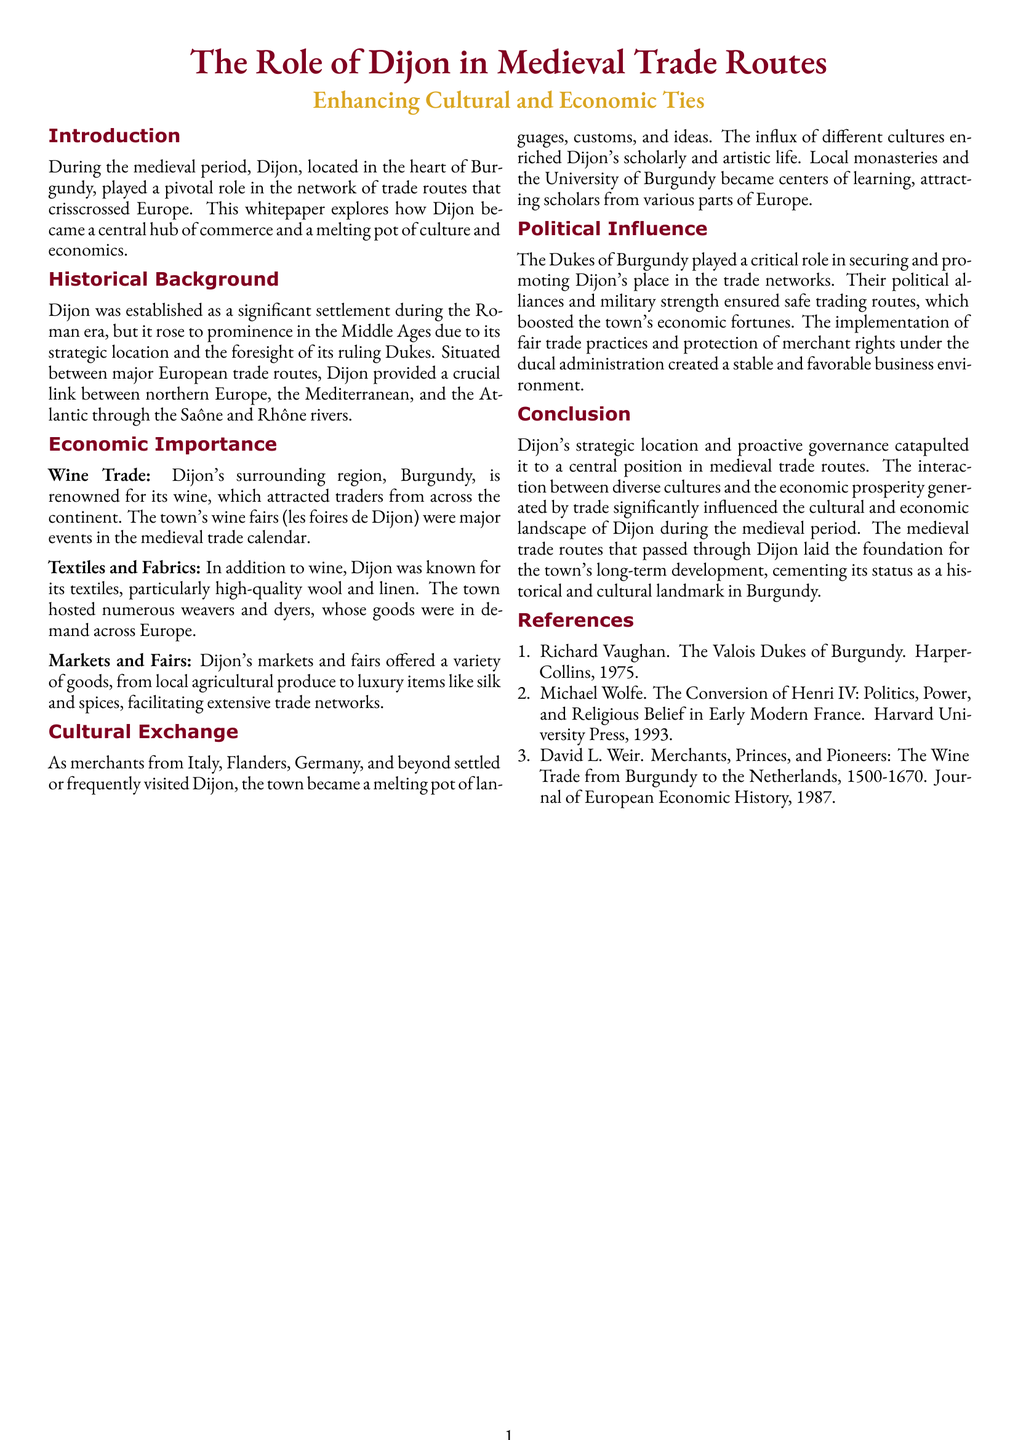what role did Dijon play during the medieval period? Dijon played a pivotal role in the network of trade routes that crisscrossed Europe.
Answer: central hub what attracted traders to Dijon? Traders were attracted to Dijon due to its renowned wine and trade fairs.
Answer: wine which industries were prominent in medieval Dijon? The prominent industries in medieval Dijon included wine trade, textiles, and fabrics.
Answer: wine, textiles, fabrics who were the key political figures supporting Dijon's trade? The key political figures supporting Dijon's trade were the Dukes of Burgundy.
Answer: Dukes of Burgundy what facilitated extensive trade networks in Dijon? Dijon's markets and fairs offered a variety of goods, facilitating extensive trade networks.
Answer: markets and fairs which rivers were crucial for Dijon's trade? The crucial rivers for Dijon's trade were the Saône and Rhône.
Answer: Saône and Rhône how did Dijon contribute to cultural exchange? As merchants settled in Dijon, the town became a melting pot of languages, customs, and ideas.
Answer: melting pot what centers of learning emerged in Dijon? Local monasteries and the University of Burgundy became centers of learning.
Answer: University of Burgundy how did fair trade practices impact Dijon's economy? Fair trade practices created a stable and favorable business environment in Dijon.
Answer: stable and favorable what is the title of the whitepaper? The title of the whitepaper is "The Role of Dijon in Medieval Trade Routes."
Answer: The Role of Dijon in Medieval Trade Routes 